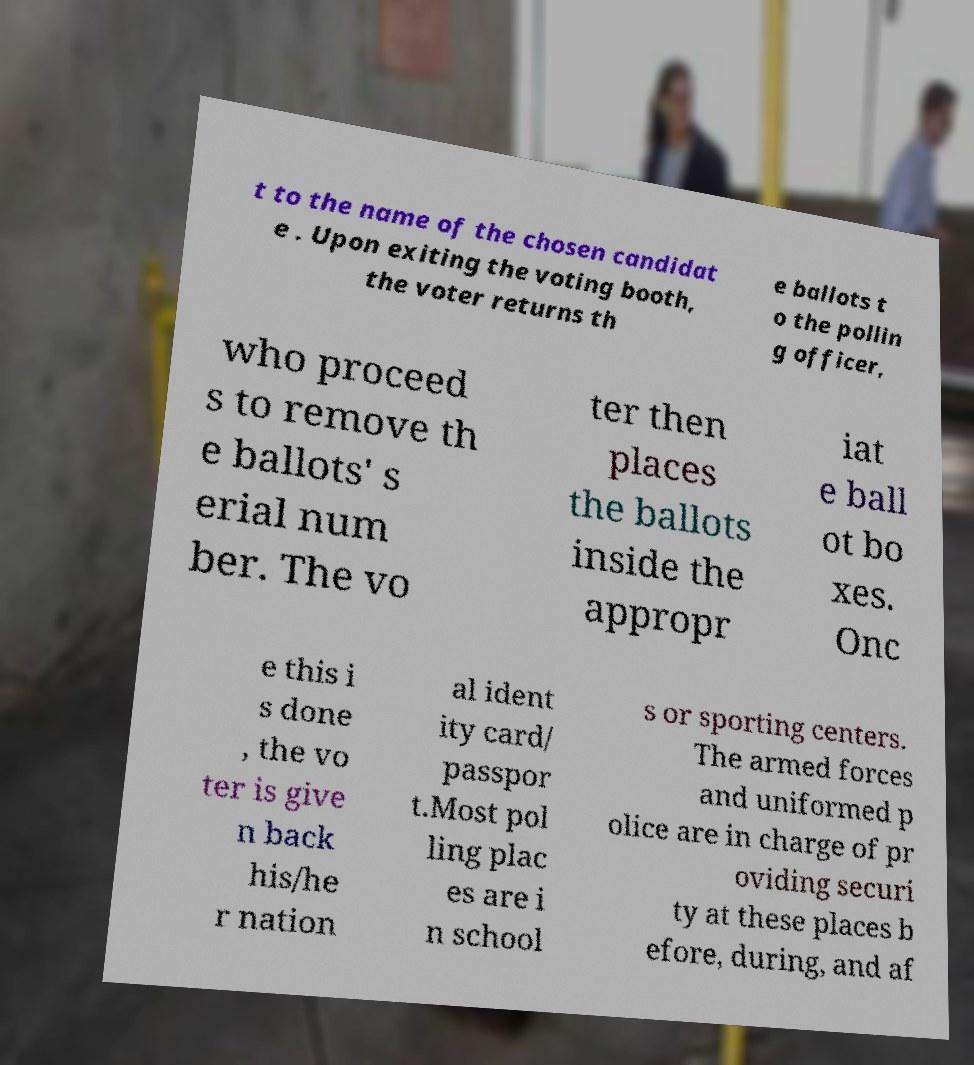I need the written content from this picture converted into text. Can you do that? t to the name of the chosen candidat e . Upon exiting the voting booth, the voter returns th e ballots t o the pollin g officer, who proceed s to remove th e ballots' s erial num ber. The vo ter then places the ballots inside the appropr iat e ball ot bo xes. Onc e this i s done , the vo ter is give n back his/he r nation al ident ity card/ passpor t.Most pol ling plac es are i n school s or sporting centers. The armed forces and uniformed p olice are in charge of pr oviding securi ty at these places b efore, during, and af 